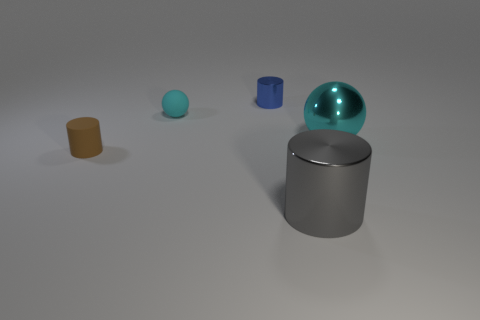Is the number of things that are in front of the gray object the same as the number of small shiny cylinders?
Give a very brief answer. No. Is there a gray cylinder that has the same size as the cyan rubber ball?
Give a very brief answer. No. Do the brown object and the ball that is right of the blue cylinder have the same size?
Offer a terse response. No. Is the number of large gray metal cylinders that are behind the brown thing the same as the number of large objects that are behind the large cyan thing?
Make the answer very short. Yes. There is a shiny object that is the same color as the small ball; what shape is it?
Provide a succinct answer. Sphere. There is a tiny thing that is in front of the cyan metal thing; what is it made of?
Your response must be concise. Rubber. Do the cyan matte object and the brown thing have the same size?
Your answer should be compact. Yes. Are there more large gray metallic cylinders that are in front of the cyan metallic object than big gray metallic blocks?
Keep it short and to the point. Yes. There is a cylinder that is made of the same material as the big gray thing; what size is it?
Provide a succinct answer. Small. There is a big shiny sphere; are there any cylinders in front of it?
Give a very brief answer. Yes. 